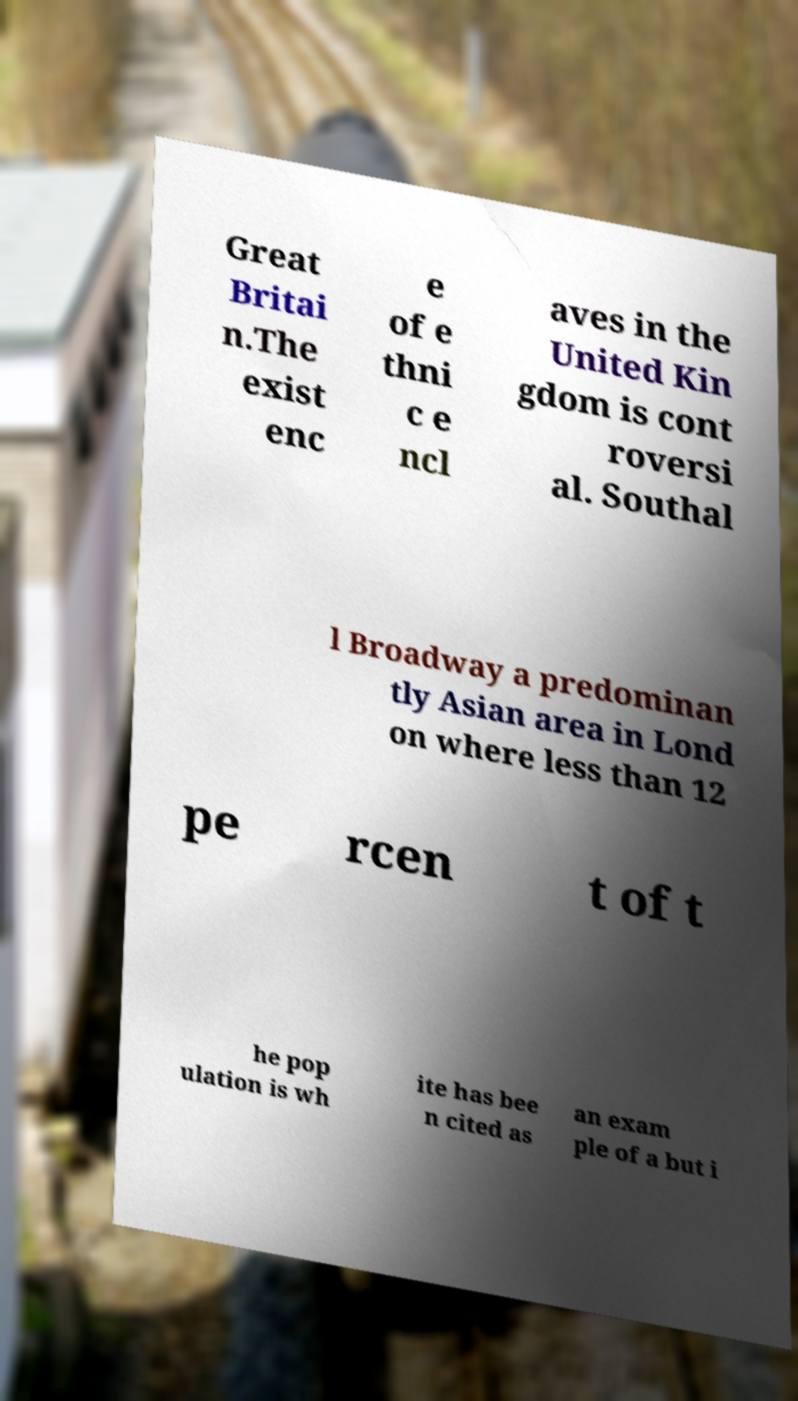What messages or text are displayed in this image? I need them in a readable, typed format. Great Britai n.The exist enc e of e thni c e ncl aves in the United Kin gdom is cont roversi al. Southal l Broadway a predominan tly Asian area in Lond on where less than 12 pe rcen t of t he pop ulation is wh ite has bee n cited as an exam ple of a but i 